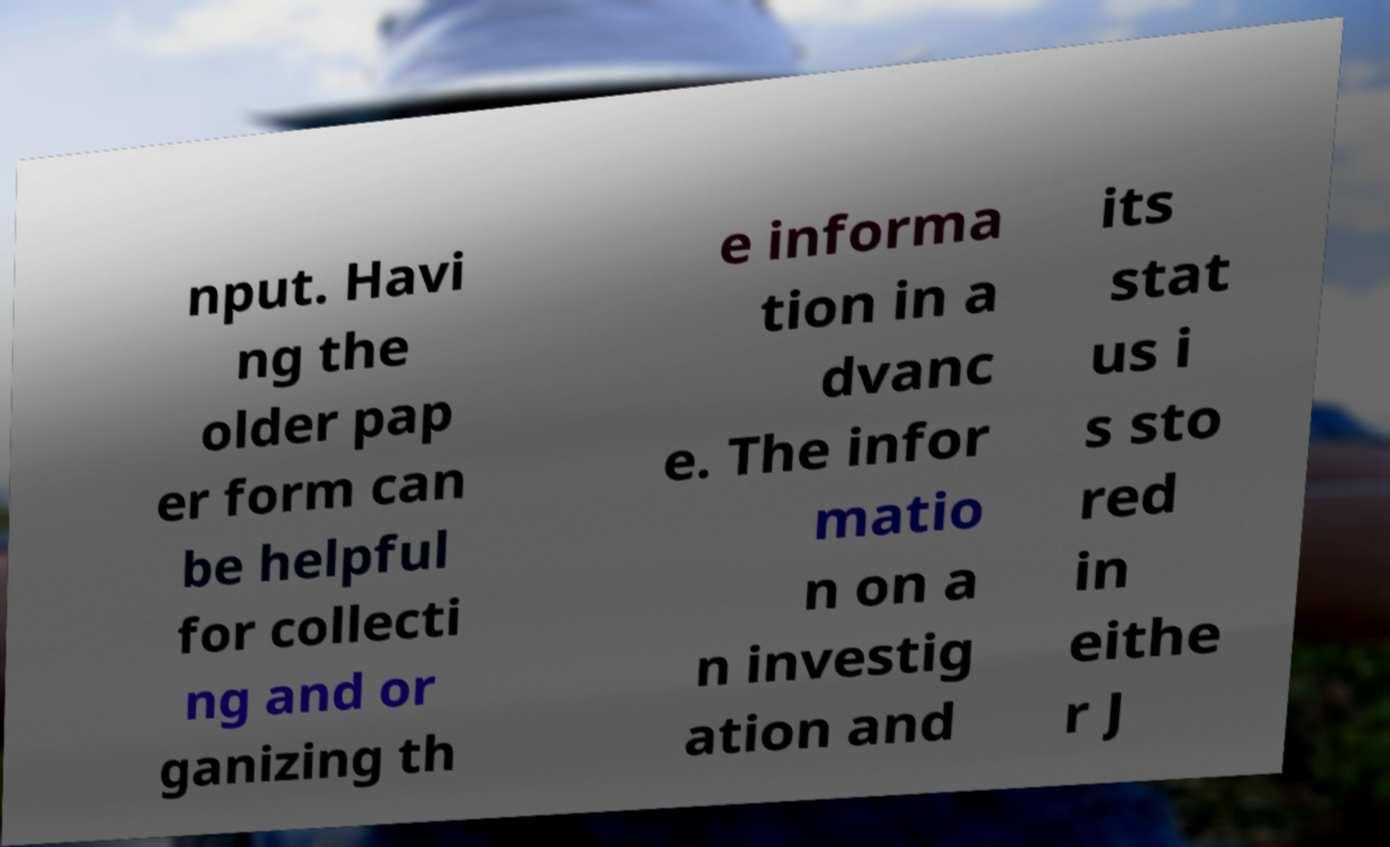Could you extract and type out the text from this image? nput. Havi ng the older pap er form can be helpful for collecti ng and or ganizing th e informa tion in a dvanc e. The infor matio n on a n investig ation and its stat us i s sto red in eithe r J 